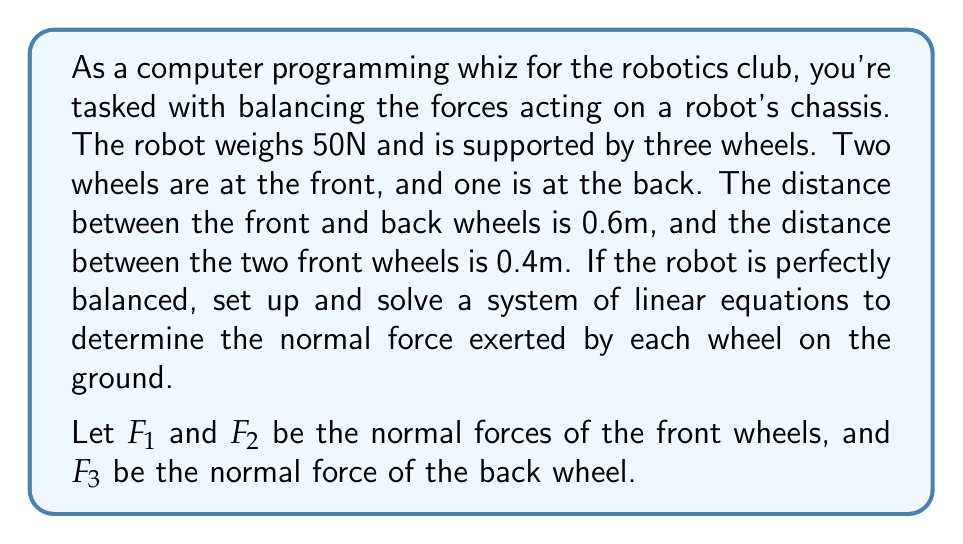Give your solution to this math problem. To solve this problem, we need to set up a system of linear equations based on the equilibrium conditions:

1. The sum of all vertical forces must be zero:
   $$F_1 + F_2 + F_3 - 50 = 0$$

2. The sum of moments about the axis through the back wheel must be zero:
   $$0.6F_1 + 0.6F_2 - 0.3 \cdot 50 = 0$$

3. The sum of moments about an axis perpendicular to the line connecting the front wheels must be zero:
   $$0.2F_1 - 0.2F_2 = 0$$

Now we have a system of three linear equations with three unknowns:

$$\begin{cases}
F_1 + F_2 + F_3 = 50 \\
0.6F_1 + 0.6F_2 = 15 \\
0.2F_1 - 0.2F_2 = 0
\end{cases}$$

From the third equation, we can deduce that $F_1 = F_2$. Let's call this value $F$.

Substituting into the second equation:
$$0.6F + 0.6F = 15$$
$$1.2F = 15$$
$$F = 12.5$$

So, $F_1 = F_2 = 12.5N$.

Substituting into the first equation:
$$12.5 + 12.5 + F_3 = 50$$
$$F_3 = 25N$$

Therefore, the normal forces exerted by each wheel are:
$F_1 = 12.5N$, $F_2 = 12.5N$, and $F_3 = 25N$.
Answer: $F_1 = 12.5N$, $F_2 = 12.5N$, $F_3 = 25N$ 